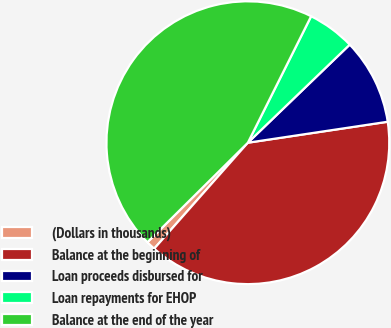<chart> <loc_0><loc_0><loc_500><loc_500><pie_chart><fcel>(Dollars in thousands)<fcel>Balance at the beginning of<fcel>Loan proceeds disbursed for<fcel>Loan repayments for EHOP<fcel>Balance at the end of the year<nl><fcel>1.05%<fcel>38.89%<fcel>9.83%<fcel>5.42%<fcel>44.81%<nl></chart> 